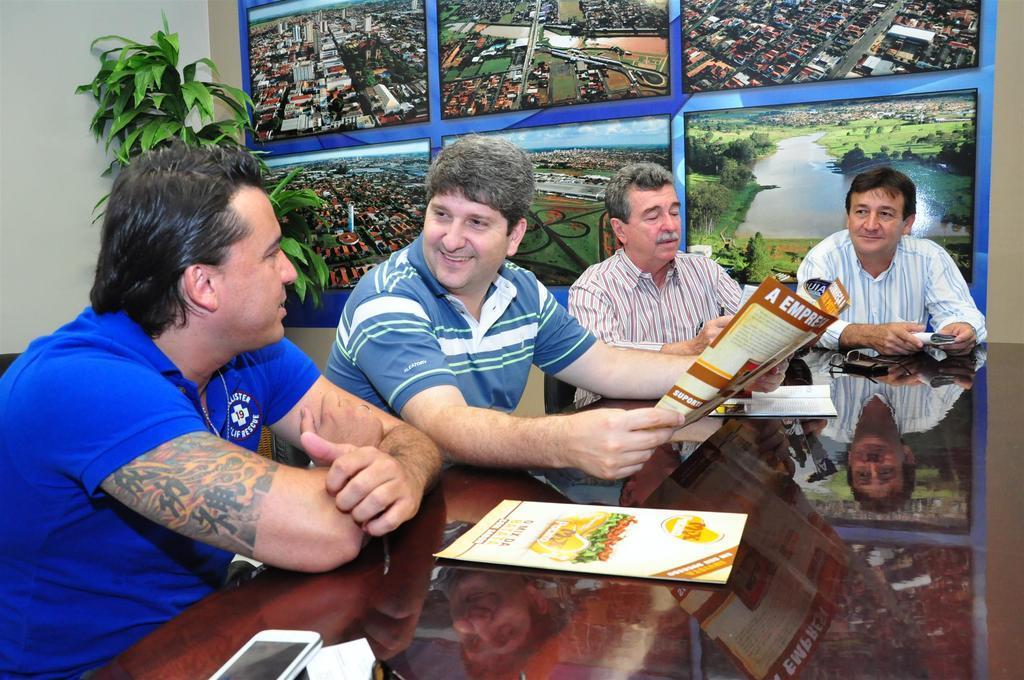Please provide a concise description of this image. This is the picture inside of the room. There are four people sitting behind the table. There are papers, phones on the table. At the back there are frames on the wall, at the back there is a plant. 